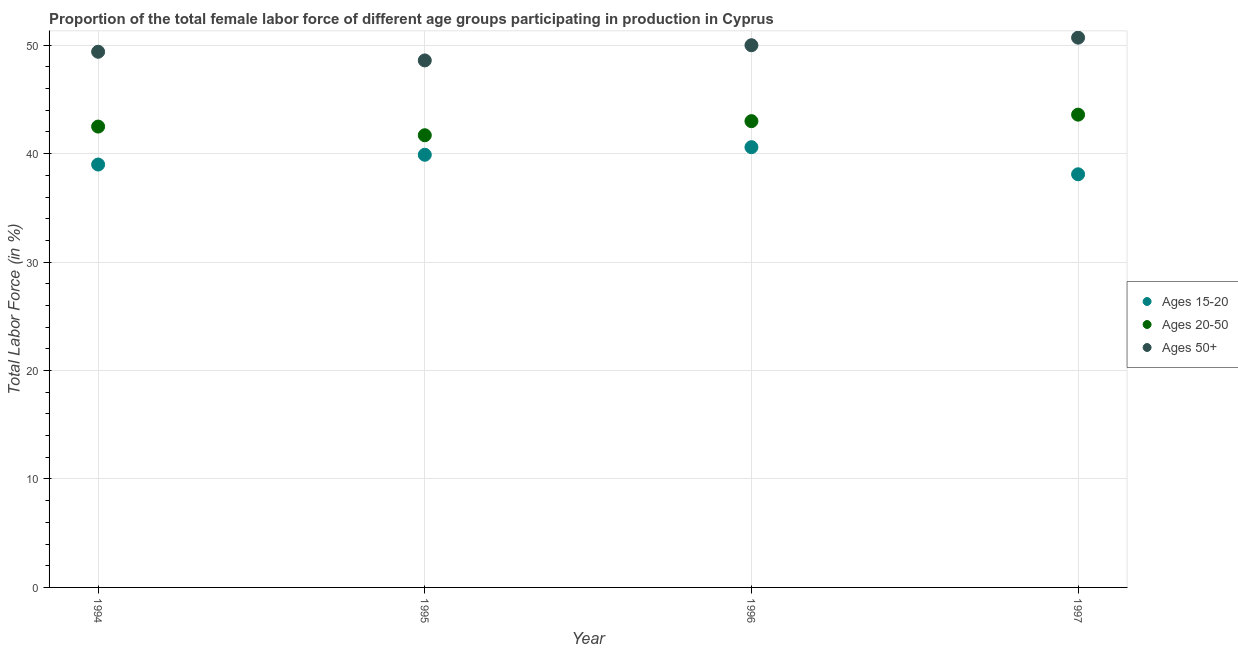Is the number of dotlines equal to the number of legend labels?
Ensure brevity in your answer.  Yes. What is the percentage of female labor force within the age group 15-20 in 1996?
Give a very brief answer. 40.6. Across all years, what is the maximum percentage of female labor force above age 50?
Your answer should be very brief. 50.7. Across all years, what is the minimum percentage of female labor force within the age group 20-50?
Your answer should be compact. 41.7. What is the total percentage of female labor force within the age group 15-20 in the graph?
Your answer should be compact. 157.6. What is the difference between the percentage of female labor force within the age group 15-20 in 1996 and that in 1997?
Keep it short and to the point. 2.5. What is the difference between the percentage of female labor force within the age group 15-20 in 1997 and the percentage of female labor force within the age group 20-50 in 1995?
Offer a very short reply. -3.6. What is the average percentage of female labor force within the age group 15-20 per year?
Provide a short and direct response. 39.4. In the year 1995, what is the difference between the percentage of female labor force within the age group 20-50 and percentage of female labor force within the age group 15-20?
Offer a very short reply. 1.8. What is the ratio of the percentage of female labor force within the age group 20-50 in 1994 to that in 1995?
Your response must be concise. 1.02. Is the percentage of female labor force above age 50 in 1994 less than that in 1997?
Ensure brevity in your answer.  Yes. Is the difference between the percentage of female labor force within the age group 15-20 in 1996 and 1997 greater than the difference between the percentage of female labor force within the age group 20-50 in 1996 and 1997?
Provide a succinct answer. Yes. What is the difference between the highest and the second highest percentage of female labor force within the age group 20-50?
Provide a short and direct response. 0.6. What is the difference between the highest and the lowest percentage of female labor force within the age group 20-50?
Provide a succinct answer. 1.9. In how many years, is the percentage of female labor force within the age group 20-50 greater than the average percentage of female labor force within the age group 20-50 taken over all years?
Provide a short and direct response. 2. How many dotlines are there?
Your answer should be compact. 3. How many years are there in the graph?
Offer a terse response. 4. Does the graph contain grids?
Make the answer very short. Yes. How are the legend labels stacked?
Your response must be concise. Vertical. What is the title of the graph?
Your answer should be compact. Proportion of the total female labor force of different age groups participating in production in Cyprus. Does "Infant(male)" appear as one of the legend labels in the graph?
Your answer should be very brief. No. What is the Total Labor Force (in %) of Ages 20-50 in 1994?
Your response must be concise. 42.5. What is the Total Labor Force (in %) in Ages 50+ in 1994?
Provide a succinct answer. 49.4. What is the Total Labor Force (in %) of Ages 15-20 in 1995?
Your response must be concise. 39.9. What is the Total Labor Force (in %) in Ages 20-50 in 1995?
Provide a short and direct response. 41.7. What is the Total Labor Force (in %) of Ages 50+ in 1995?
Your answer should be compact. 48.6. What is the Total Labor Force (in %) of Ages 15-20 in 1996?
Provide a short and direct response. 40.6. What is the Total Labor Force (in %) of Ages 15-20 in 1997?
Keep it short and to the point. 38.1. What is the Total Labor Force (in %) in Ages 20-50 in 1997?
Make the answer very short. 43.6. What is the Total Labor Force (in %) of Ages 50+ in 1997?
Offer a very short reply. 50.7. Across all years, what is the maximum Total Labor Force (in %) of Ages 15-20?
Give a very brief answer. 40.6. Across all years, what is the maximum Total Labor Force (in %) of Ages 20-50?
Offer a very short reply. 43.6. Across all years, what is the maximum Total Labor Force (in %) of Ages 50+?
Give a very brief answer. 50.7. Across all years, what is the minimum Total Labor Force (in %) of Ages 15-20?
Provide a succinct answer. 38.1. Across all years, what is the minimum Total Labor Force (in %) of Ages 20-50?
Make the answer very short. 41.7. Across all years, what is the minimum Total Labor Force (in %) in Ages 50+?
Provide a succinct answer. 48.6. What is the total Total Labor Force (in %) of Ages 15-20 in the graph?
Make the answer very short. 157.6. What is the total Total Labor Force (in %) of Ages 20-50 in the graph?
Keep it short and to the point. 170.8. What is the total Total Labor Force (in %) of Ages 50+ in the graph?
Offer a terse response. 198.7. What is the difference between the Total Labor Force (in %) of Ages 15-20 in 1994 and that in 1995?
Offer a terse response. -0.9. What is the difference between the Total Labor Force (in %) in Ages 50+ in 1994 and that in 1996?
Give a very brief answer. -0.6. What is the difference between the Total Labor Force (in %) in Ages 20-50 in 1994 and that in 1997?
Keep it short and to the point. -1.1. What is the difference between the Total Labor Force (in %) in Ages 50+ in 1994 and that in 1997?
Make the answer very short. -1.3. What is the difference between the Total Labor Force (in %) of Ages 50+ in 1995 and that in 1996?
Provide a short and direct response. -1.4. What is the difference between the Total Labor Force (in %) of Ages 15-20 in 1995 and that in 1997?
Make the answer very short. 1.8. What is the difference between the Total Labor Force (in %) in Ages 15-20 in 1996 and that in 1997?
Ensure brevity in your answer.  2.5. What is the difference between the Total Labor Force (in %) in Ages 20-50 in 1996 and that in 1997?
Ensure brevity in your answer.  -0.6. What is the difference between the Total Labor Force (in %) of Ages 50+ in 1996 and that in 1997?
Provide a succinct answer. -0.7. What is the difference between the Total Labor Force (in %) of Ages 15-20 in 1994 and the Total Labor Force (in %) of Ages 50+ in 1995?
Your answer should be compact. -9.6. What is the difference between the Total Labor Force (in %) of Ages 20-50 in 1994 and the Total Labor Force (in %) of Ages 50+ in 1995?
Offer a very short reply. -6.1. What is the difference between the Total Labor Force (in %) in Ages 15-20 in 1994 and the Total Labor Force (in %) in Ages 20-50 in 1996?
Offer a terse response. -4. What is the difference between the Total Labor Force (in %) in Ages 15-20 in 1994 and the Total Labor Force (in %) in Ages 20-50 in 1997?
Make the answer very short. -4.6. What is the difference between the Total Labor Force (in %) in Ages 20-50 in 1994 and the Total Labor Force (in %) in Ages 50+ in 1997?
Provide a succinct answer. -8.2. What is the difference between the Total Labor Force (in %) in Ages 15-20 in 1995 and the Total Labor Force (in %) in Ages 50+ in 1996?
Keep it short and to the point. -10.1. What is the difference between the Total Labor Force (in %) of Ages 20-50 in 1995 and the Total Labor Force (in %) of Ages 50+ in 1997?
Give a very brief answer. -9. What is the difference between the Total Labor Force (in %) in Ages 15-20 in 1996 and the Total Labor Force (in %) in Ages 20-50 in 1997?
Offer a terse response. -3. What is the average Total Labor Force (in %) in Ages 15-20 per year?
Provide a short and direct response. 39.4. What is the average Total Labor Force (in %) in Ages 20-50 per year?
Offer a very short reply. 42.7. What is the average Total Labor Force (in %) of Ages 50+ per year?
Give a very brief answer. 49.67. In the year 1994, what is the difference between the Total Labor Force (in %) in Ages 15-20 and Total Labor Force (in %) in Ages 20-50?
Provide a succinct answer. -3.5. In the year 1995, what is the difference between the Total Labor Force (in %) of Ages 15-20 and Total Labor Force (in %) of Ages 20-50?
Keep it short and to the point. -1.8. In the year 1995, what is the difference between the Total Labor Force (in %) in Ages 15-20 and Total Labor Force (in %) in Ages 50+?
Make the answer very short. -8.7. In the year 1997, what is the difference between the Total Labor Force (in %) in Ages 15-20 and Total Labor Force (in %) in Ages 20-50?
Ensure brevity in your answer.  -5.5. In the year 1997, what is the difference between the Total Labor Force (in %) of Ages 15-20 and Total Labor Force (in %) of Ages 50+?
Give a very brief answer. -12.6. What is the ratio of the Total Labor Force (in %) in Ages 15-20 in 1994 to that in 1995?
Provide a succinct answer. 0.98. What is the ratio of the Total Labor Force (in %) of Ages 20-50 in 1994 to that in 1995?
Your response must be concise. 1.02. What is the ratio of the Total Labor Force (in %) in Ages 50+ in 1994 to that in 1995?
Provide a succinct answer. 1.02. What is the ratio of the Total Labor Force (in %) in Ages 15-20 in 1994 to that in 1996?
Make the answer very short. 0.96. What is the ratio of the Total Labor Force (in %) of Ages 20-50 in 1994 to that in 1996?
Your answer should be compact. 0.99. What is the ratio of the Total Labor Force (in %) in Ages 15-20 in 1994 to that in 1997?
Your answer should be very brief. 1.02. What is the ratio of the Total Labor Force (in %) in Ages 20-50 in 1994 to that in 1997?
Offer a very short reply. 0.97. What is the ratio of the Total Labor Force (in %) of Ages 50+ in 1994 to that in 1997?
Keep it short and to the point. 0.97. What is the ratio of the Total Labor Force (in %) in Ages 15-20 in 1995 to that in 1996?
Your answer should be compact. 0.98. What is the ratio of the Total Labor Force (in %) of Ages 20-50 in 1995 to that in 1996?
Keep it short and to the point. 0.97. What is the ratio of the Total Labor Force (in %) in Ages 50+ in 1995 to that in 1996?
Offer a terse response. 0.97. What is the ratio of the Total Labor Force (in %) of Ages 15-20 in 1995 to that in 1997?
Make the answer very short. 1.05. What is the ratio of the Total Labor Force (in %) of Ages 20-50 in 1995 to that in 1997?
Your answer should be very brief. 0.96. What is the ratio of the Total Labor Force (in %) in Ages 50+ in 1995 to that in 1997?
Offer a very short reply. 0.96. What is the ratio of the Total Labor Force (in %) of Ages 15-20 in 1996 to that in 1997?
Ensure brevity in your answer.  1.07. What is the ratio of the Total Labor Force (in %) of Ages 20-50 in 1996 to that in 1997?
Ensure brevity in your answer.  0.99. What is the ratio of the Total Labor Force (in %) in Ages 50+ in 1996 to that in 1997?
Ensure brevity in your answer.  0.99. What is the difference between the highest and the lowest Total Labor Force (in %) of Ages 20-50?
Your response must be concise. 1.9. What is the difference between the highest and the lowest Total Labor Force (in %) of Ages 50+?
Give a very brief answer. 2.1. 